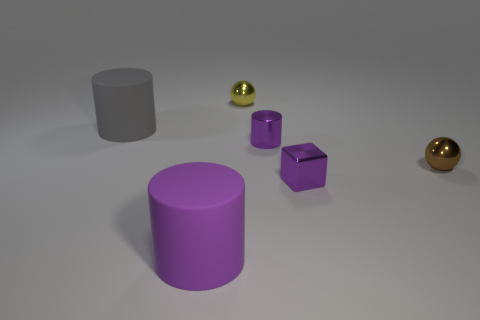Subtract all purple metallic cylinders. How many cylinders are left? 2 Subtract all cyan spheres. How many purple cylinders are left? 2 Add 1 large gray metallic cylinders. How many objects exist? 7 Subtract all cubes. How many objects are left? 5 Subtract 0 cyan cubes. How many objects are left? 6 Subtract all tiny cubes. Subtract all small yellow metallic balls. How many objects are left? 4 Add 3 gray objects. How many gray objects are left? 4 Add 3 gray cylinders. How many gray cylinders exist? 4 